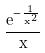<formula> <loc_0><loc_0><loc_500><loc_500>\frac { e ^ { - \frac { 1 } { x ^ { 2 } } } } { x }</formula> 